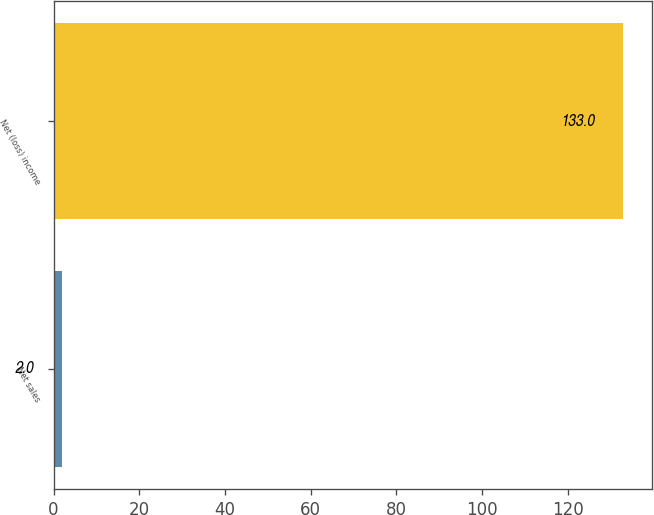Convert chart to OTSL. <chart><loc_0><loc_0><loc_500><loc_500><bar_chart><fcel>Net sales<fcel>Net (loss) income<nl><fcel>2<fcel>133<nl></chart> 